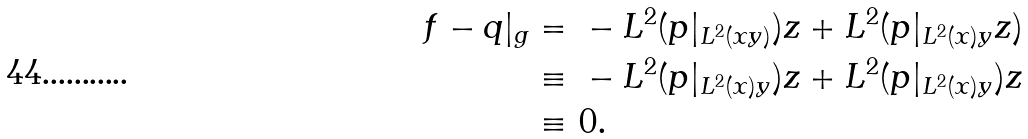<formula> <loc_0><loc_0><loc_500><loc_500>f - q | _ { g } = & \ - L ^ { 2 } ( p | _ { L ^ { 2 } ( x y ) } ) z + L ^ { 2 } ( p | _ { L ^ { 2 } ( x ) y } z ) \\ \equiv & \ - L ^ { 2 } ( p | _ { L ^ { 2 } ( x ) y } ) z + L ^ { 2 } ( p | _ { L ^ { 2 } ( x ) y } ) z \\ \equiv & \ 0 .</formula> 